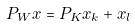<formula> <loc_0><loc_0><loc_500><loc_500>P _ { W } x = P _ { K } x _ { k } + x _ { l }</formula> 